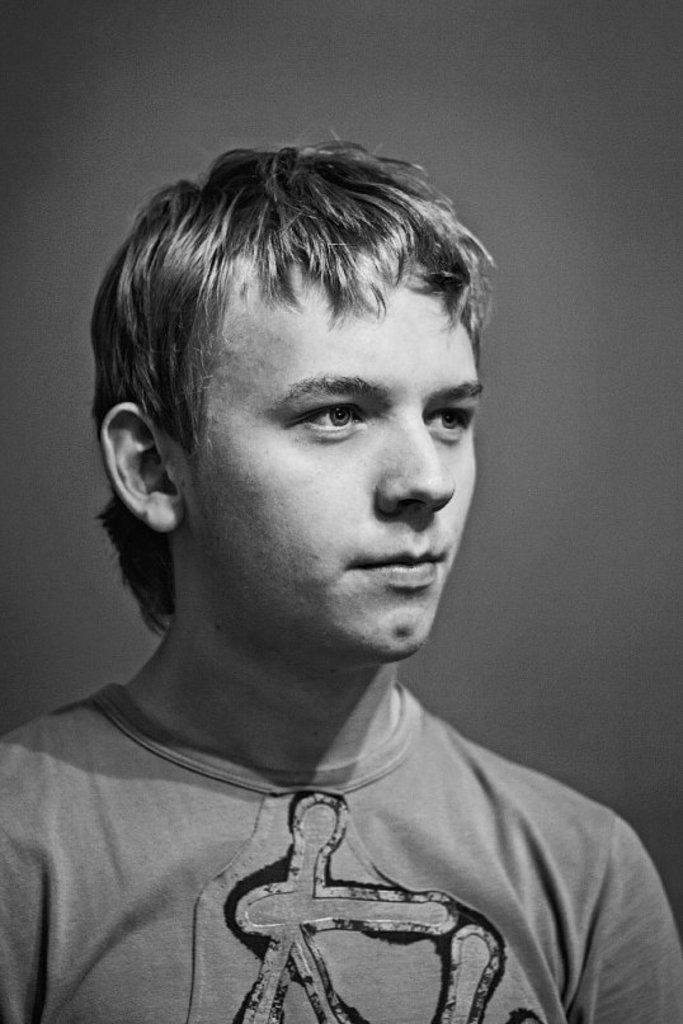What is the color scheme of the image? The image is black and white. Can you describe the main subject of the image? There is a man in the image. What type of mine is visible in the image? There is no mine present in the image; it only features a man in a black and white setting. Can you describe the man's actions in the image, such as kicking or playing with a pot? There is no indication of the man kicking or playing with a pot in the image; he is simply present in the black and white setting. 